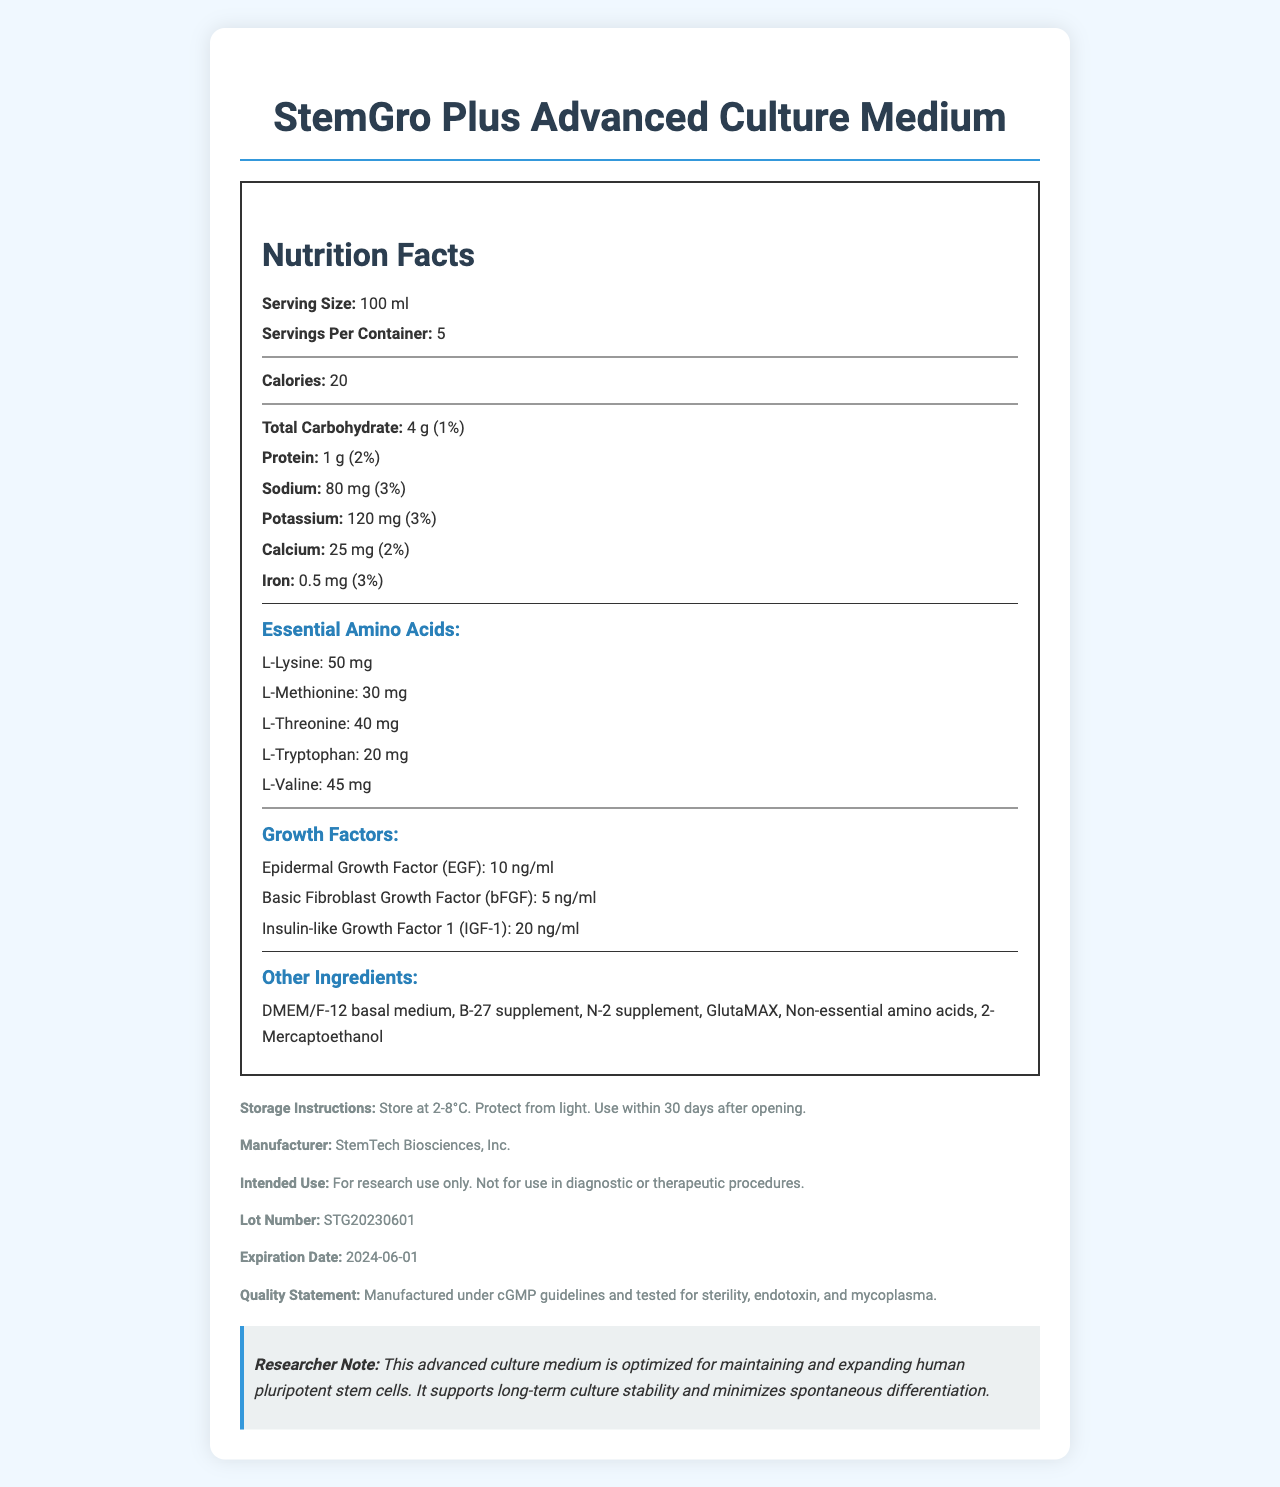What is the serving size of StemGro Plus Advanced Culture Medium? The document lists the serving size of StemGro Plus Advanced Culture Medium as 100 ml.
Answer: 100 ml How many essential amino acids are listed in the nutrition facts? The document specifies five essential amino acids: L-Lysine, L-Methionine, L-Threonine, L-Tryptophan, and L-Valine.
Answer: 5 Which growth factor is present in the highest amount in the culture medium? Insulin-like Growth Factor 1 (IGF-1) is present at 20 ng/ml, which is higher than the amounts of Epidermal Growth Factor (EGF) at 10 ng/ml and Basic Fibroblast Growth Factor (bFGF) at 5 ng/ml.
Answer: Insulin-like Growth Factor 1 (IGF-1) What is the daily value percentage of sodium in one serving? The document lists the sodium content as 80 mg, which corresponds to 3% of the daily value.
Answer: 3% What is the recommended storage temperature for the culture medium? The storage instructions state that this product should be stored at 2-8°C.
Answer: 2-8°C How many calories does each serving of StemGro Plus Advanced Culture Medium contain? The document states that each serving contains 20 calories.
Answer: 20 What is the intended use of this culture medium? A. For therapeutic use B. For diagnostic procedures C. For research use only D. For dietary supplementation The intended use is stated as "For research use only."
Answer: C What is the expiration date of this product? A. 2023-06-01 B. 2024-06-01 C. 2025-06-01 D. 2026-06-01 The document lists the expiration date as 2024-06-01.
Answer: B Is this culture medium tested for sterility, endotoxin, and mycoplasma? The quality statement mentions that the medium is manufactured under cGMP guidelines and tested for sterility, endotoxin, and mycoplasma.
Answer: Yes Summarize the main information provided by this document. The StemGro Plus Advanced Culture Medium is detailed, highlighting its suitability for long-term culture stability, essential nutrients, and compliance with quality guidelines.
Answer: This document provides nutritional and ingredient details for the StemGro Plus Advanced Culture Medium, designed for human pluripotent stem cells. It includes a nutrition facts label listing carbohydrates, protein, sodium, potassium, calcium, iron, essential amino acids, and growth factors. The document also includes storage instructions, intended use, lot number, expiration date, and a quality statement emphasizing the product's sterility and testing procedures. What is the amount of potassium in one serving of the medium? The document specifies that one serving contains 120 mg of potassium.
Answer: 120 mg Can this medium be used for therapeutic or diagnostic procedures? The intended use section states that the product is for research use only and not for therapeutic or diagnostic procedures.
Answer: No Which of the following is not an ingredient in the StemGro Plus Advanced Culture Medium? A. B-27 supplement B. FBS (Fetal Bovine Serum) C. DMEM/F-12 basal medium D. 2-Mercaptoethanol The list of ingredients includes B-27 supplement, DMEM/F-12 basal medium, and 2-Mercaptoethanol, but not FBS (Fetal Bovine Serum).
Answer: B What is the lot number of this product? The document lists the lot number as STG20230601.
Answer: STG20230601 How many servings are there per container of the StemGro Plus Advanced Culture Medium? The document specifies that there are 5 servings per container.
Answer: 5 How much protein is in each serving of the medium? The nutrition facts state that each serving contains 1 gram of protein.
Answer: 1 g What types of cells is this culture medium optimized for? The researcher's note mentions that this medium is optimized for maintaining and expanding human pluripotent stem cells.
Answer: Human pluripotent stem cells Does the document provide a user manual or detailed instructions on how to prepare the medium? The document lists the ingredients, nutritional information, and storage instructions but does not provide a detailed user manual or preparation instructions.
Answer: Not enough information Is GlutaMAX included in the other ingredients of the medium? The document lists GlutaMAX among the other ingredients.
Answer: Yes 